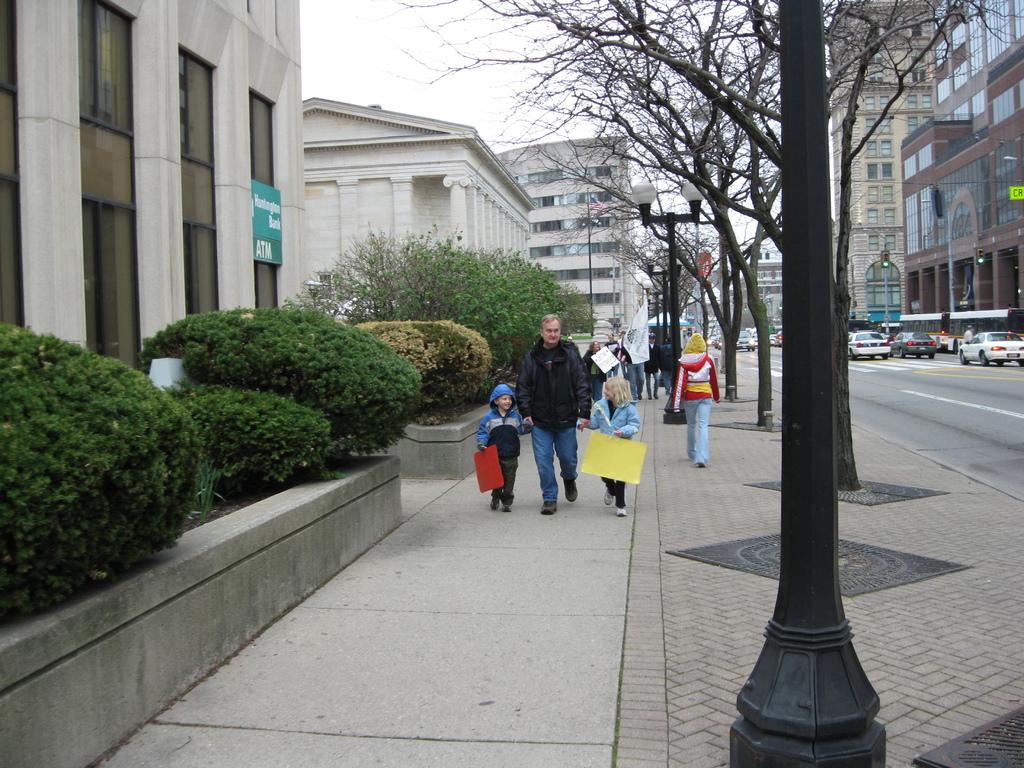What is located in the foreground of the image? There are plants and a pole in the foreground of the image. What can be seen in the background of the image? There are people, poles, trees, vehicles, buildings, and the sky visible in the background of the image. How many types of structures are present in the image? There are poles and buildings present in the image. What type of cup is being held by the hands in the image? There are no cups or hands present in the image. What type of structure is being built by the people in the image? There are no structures being built by people in the image. 